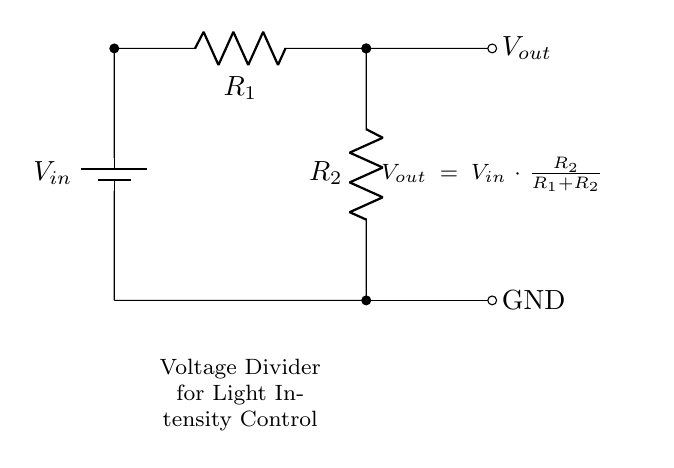What is the input voltage of the circuit? The input voltage, represented as V_{in}, is shown in the diagram but not given a specific value. It's typically the source voltage connected to the battery.
Answer: V_{in} What are the resistance values in this circuit? The circuit contains two resistors: R_1 and R_2. The values of these resistors are not specified in the diagram but are essential for calculating output voltage.
Answer: R_1 and R_2 What is the formula for the output voltage? The formula for the output voltage, V_{out}, is provided in the circuit: V_{out} = V_{in} * (R_2 / (R_1 + R_2)). This expression determines the voltage drop across R_2 based on the input voltage and resistance values.
Answer: V_{out} = V_{in} * (R_2 / (R_1 + R_2)) Which component limits the current in this circuit? Resistors R_1 and R_2 both limit the current. Resistors act to reduce current flow based on their resistance values. Together, they determine how much current passes through the circuit according to Ohm's law.
Answer: R_1 and R_2 How does changing R_1 affect V_{out}? Changing R_1 affects the output voltage inversely. As R_1 increases, the total resistance increases, leading to a decrease in the ratio R_2 / (R_1 + R_2), which results in a lower V_{out}.
Answer: Decreases V_{out} What defines the type of circuit represented here? This circuit is a voltage divider circuit, designed specifically to control the voltage and therefore light intensity in applications such as a psychology lab. It uses resistors to divide the voltage based on their ratio.
Answer: Voltage divider circuit 